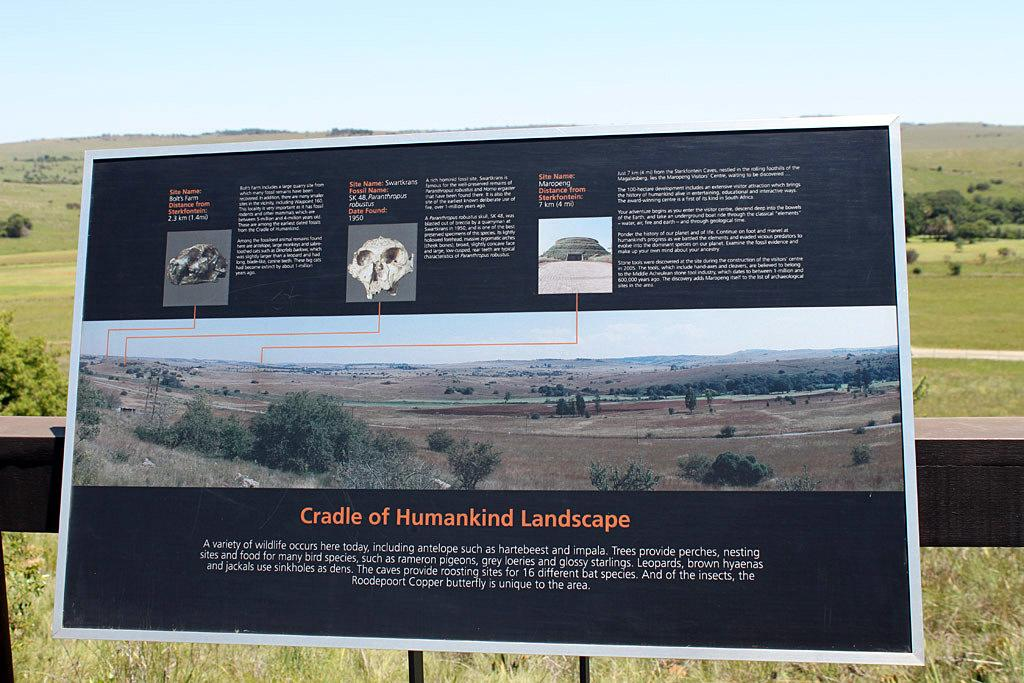<image>
Present a compact description of the photo's key features. Sign for a green landscape that reads "Cradle of Humankind Landscape". 